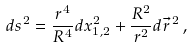<formula> <loc_0><loc_0><loc_500><loc_500>d s ^ { 2 } = \frac { r ^ { 4 } } { R ^ { 4 } } d x _ { 1 , 2 } ^ { 2 } + \frac { R ^ { 2 } } { r ^ { 2 } } d \vec { r } ^ { \, 2 } \, ,</formula> 